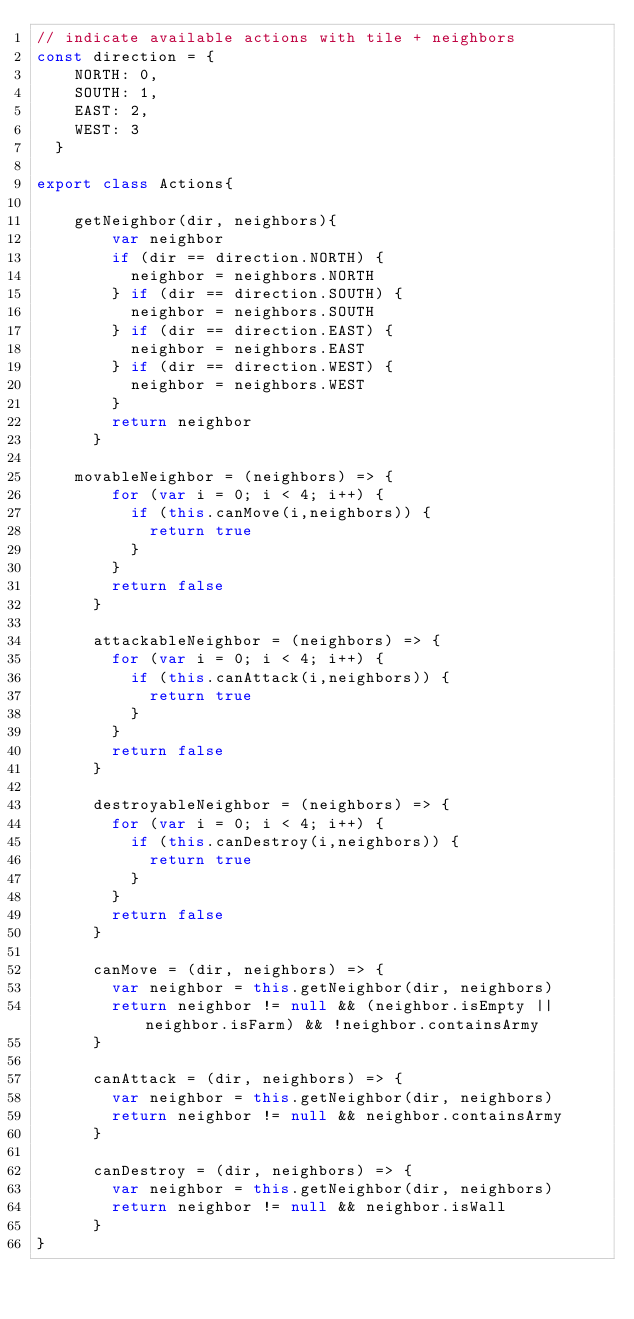Convert code to text. <code><loc_0><loc_0><loc_500><loc_500><_JavaScript_>// indicate available actions with tile + neighbors
const direction = {
    NORTH: 0,
    SOUTH: 1,
    EAST: 2,
    WEST: 3
  }

export class Actions{

    getNeighbor(dir, neighbors){
        var neighbor
        if (dir == direction.NORTH) {
          neighbor = neighbors.NORTH
        } if (dir == direction.SOUTH) {
          neighbor = neighbors.SOUTH
        } if (dir == direction.EAST) {
          neighbor = neighbors.EAST
        } if (dir == direction.WEST) {
          neighbor = neighbors.WEST
        }
        return neighbor
      }

    movableNeighbor = (neighbors) => {
        for (var i = 0; i < 4; i++) {
          if (this.canMove(i,neighbors)) {
            return true
          }
        }
        return false
      }
    
      attackableNeighbor = (neighbors) => {
        for (var i = 0; i < 4; i++) {
          if (this.canAttack(i,neighbors)) {
            return true
          }
        }
        return false
      }
    
      destroyableNeighbor = (neighbors) => {
        for (var i = 0; i < 4; i++) {
          if (this.canDestroy(i,neighbors)) {
            return true
          }
        }
        return false
      }
    
      canMove = (dir, neighbors) => {
        var neighbor = this.getNeighbor(dir, neighbors)
        return neighbor != null && (neighbor.isEmpty || neighbor.isFarm) && !neighbor.containsArmy
      }
    
      canAttack = (dir, neighbors) => {
        var neighbor = this.getNeighbor(dir, neighbors)
        return neighbor != null && neighbor.containsArmy
      }
    
      canDestroy = (dir, neighbors) => {
        var neighbor = this.getNeighbor(dir, neighbors)
        return neighbor != null && neighbor.isWall
      }
}</code> 